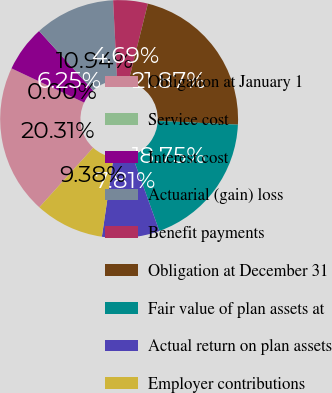Convert chart. <chart><loc_0><loc_0><loc_500><loc_500><pie_chart><fcel>Obligation at January 1<fcel>Service cost<fcel>Interest cost<fcel>Actuarial (gain) loss<fcel>Benefit payments<fcel>Obligation at December 31<fcel>Fair value of plan assets at<fcel>Actual return on plan assets<fcel>Employer contributions<nl><fcel>20.31%<fcel>0.0%<fcel>6.25%<fcel>10.94%<fcel>4.69%<fcel>21.87%<fcel>18.75%<fcel>7.81%<fcel>9.38%<nl></chart> 